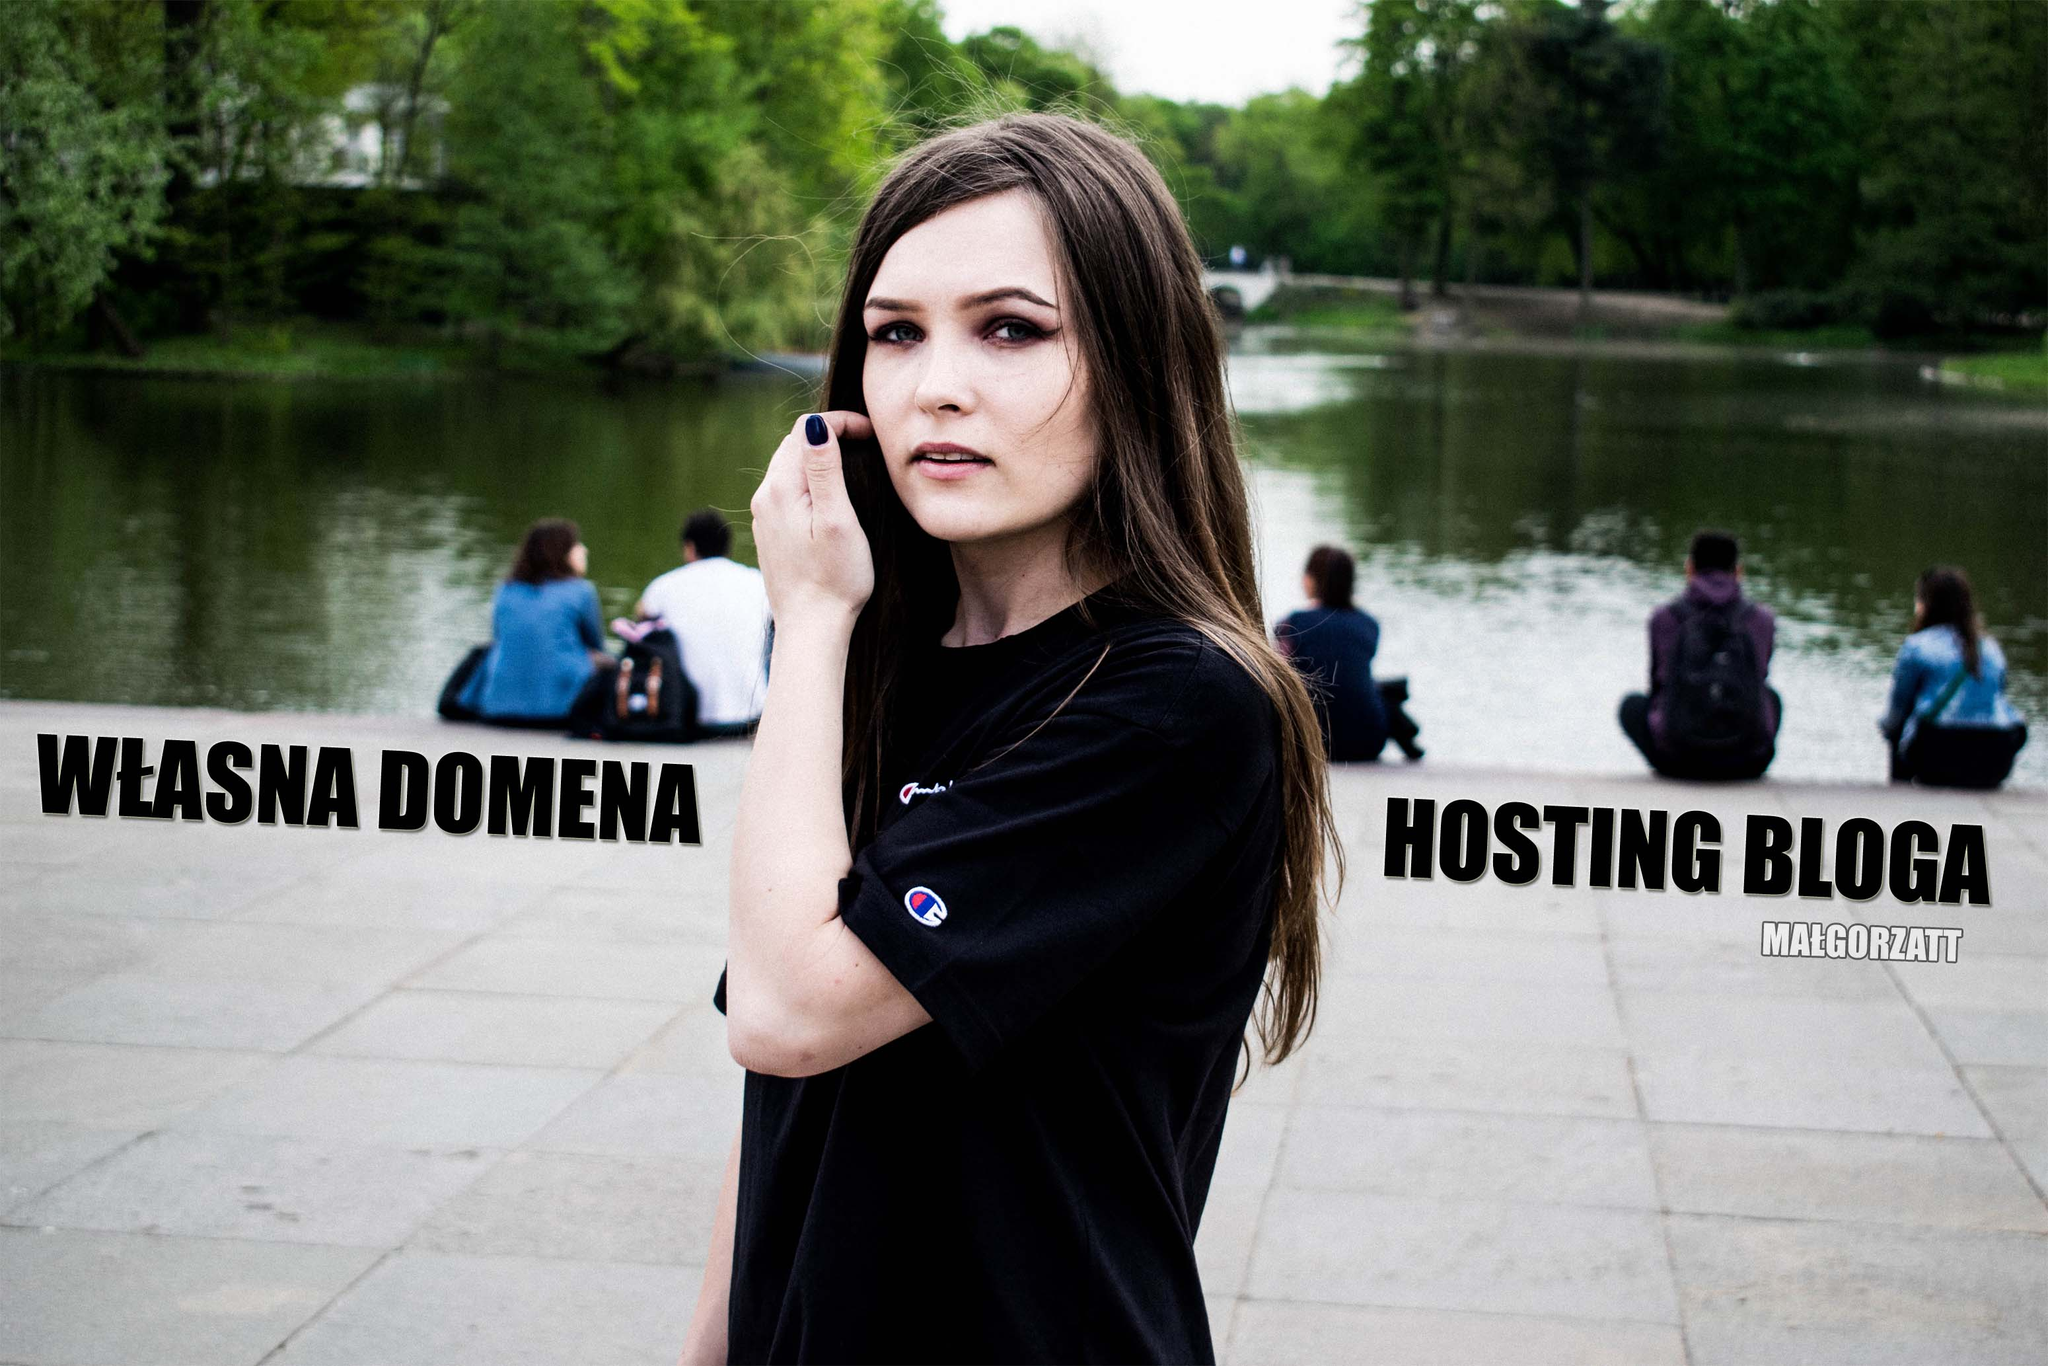Imagine a magical fantasy twist to this image. Get very creative! Picture the park as an enchanted realm. The pond glows with an ethereal light, and mystical creatures peek from behind ancient trees. The woman, with a touch, transforms the text into luminescent glyphs. These glyphs float into the air, reorganizing into secret spells and incantations. As she whispers ancient words, the park metamorphoses—flowers bloom instantaneously, paths light up with guiding pixie dust, and a majestic dragon, guardian of the 'WŁASNA DOMENA' realm, emerges to offer her the power to conjure websites with a mere thought. Each ‘blog’ hosted is a portal to different fantastical worlds waiting to be explored. 